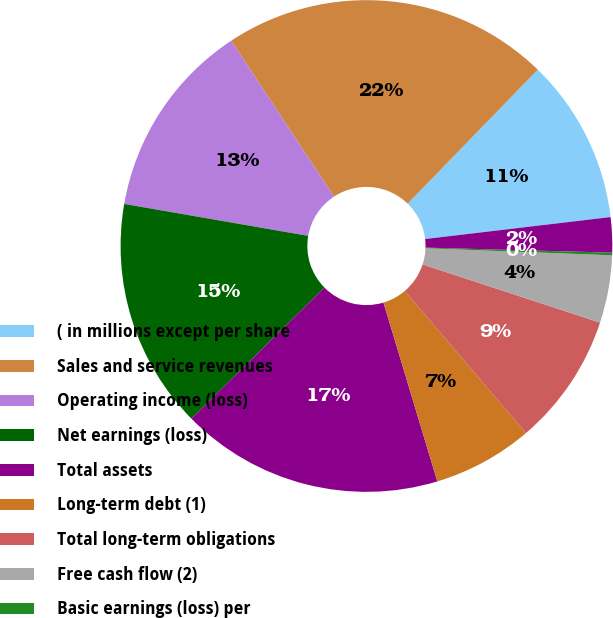<chart> <loc_0><loc_0><loc_500><loc_500><pie_chart><fcel>( in millions except per share<fcel>Sales and service revenues<fcel>Operating income (loss)<fcel>Net earnings (loss)<fcel>Total assets<fcel>Long-term debt (1)<fcel>Total long-term obligations<fcel>Free cash flow (2)<fcel>Basic earnings (loss) per<fcel>Diluted earnings (loss) per<nl><fcel>10.85%<fcel>21.54%<fcel>12.99%<fcel>15.13%<fcel>17.26%<fcel>6.58%<fcel>8.72%<fcel>4.44%<fcel>0.17%<fcel>2.31%<nl></chart> 